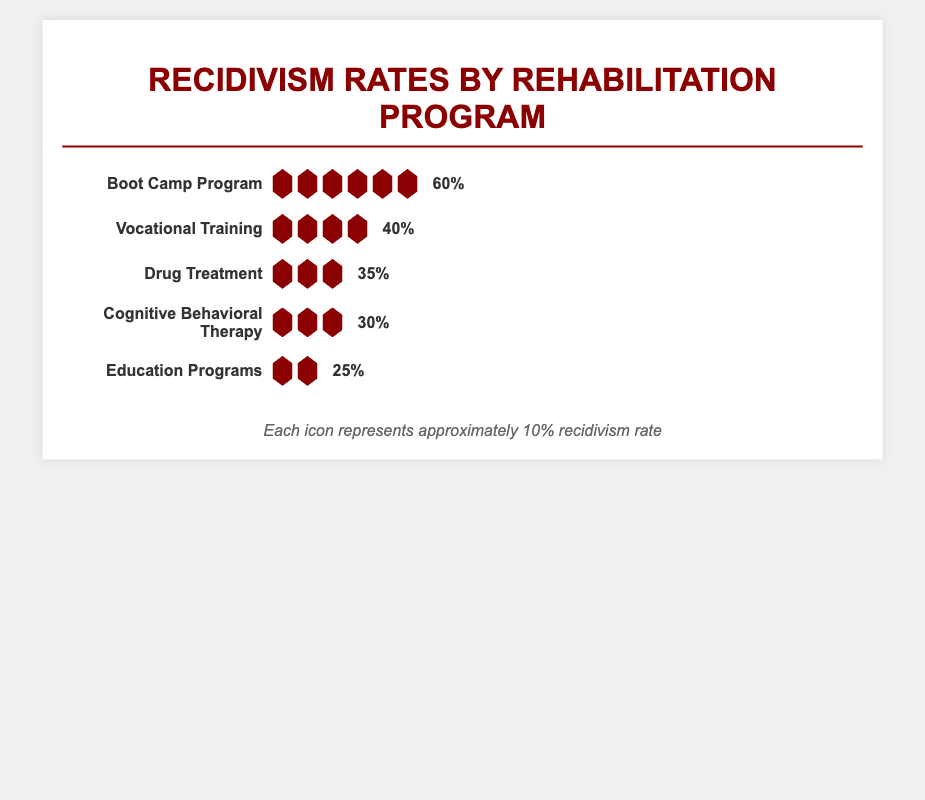How many icons are used to represent the recidivism rate for the Drug Treatment program? The Drug Treatment program has three icons visible in the visual depiction of recidivism rates, and each icon represents approximately 10%.
Answer: 3 Which rehabilitation program has the lowest recidivism rate? The lowest recidivism rate is shown by the Education Programs, which has 2 icons, each representing 10%, totaling 25%.
Answer: Education Programs What is the difference in recidivism rates between Vocational Training and Cognitive Behavioral Therapy? Vocational Training has a recidivism rate of 40% (4 icons), and Cognitive Behavioral Therapy has a rate of 30% (3 icons). The difference between them is 40% - 30% which equals 10%.
Answer: 10% How many more icons does the Boot Camp Program have compared to the Education Programs? The Boot Camp Program has 6 icons, while the Education Programs have 2 icons. The difference in the number of icons is 6 - 2 = 4.
Answer: 4 Which two programs have the same number of icons representing their recidivism rates, and what is that number? The Drug Treatment and Cognitive Behavioral Therapy programs both have 3 icons representing their recidivism rates.
Answer: Drug Treatment and Cognitive Behavioral Therapy, 3 If each icon represents 10%, what is the total recidivism rate for all five programs combined? Summing up each program’s recidivism rates: Boot Camp Program (60%), Vocational Training (40%), Drug Treatment (35%), Cognitive Behavioral Therapy (30%), and Education Programs (25%): 60 + 40 + 35 + 30 + 25 = 190%.
Answer: 190% Which program has exactly half the recidivism rate of the Boot Camp Program? The Boot Camp Program has a recidivism rate of 60%. Half of that is 30%, which matches the recidivism rate of Cognitive Behavioral Therapy.
Answer: Cognitive Behavioral Therapy 